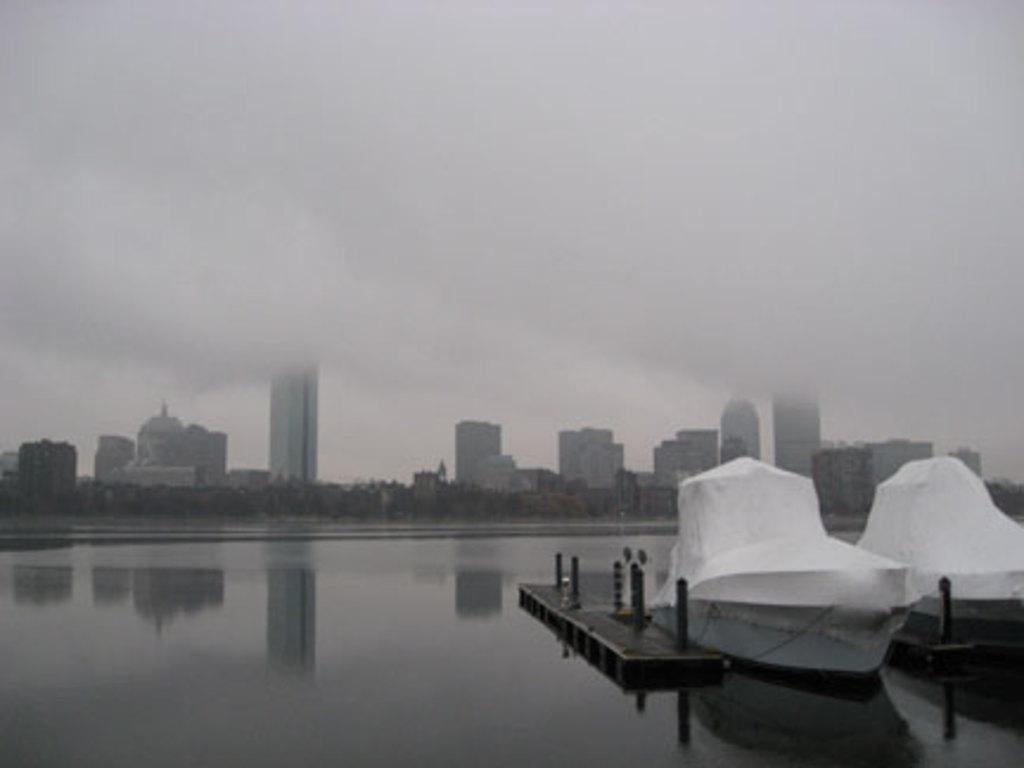Please provide a concise description of this image. In the foreground I can see boats in the water and a fence. In the background I can see trees, buildings and the sky. This image is taken may be during a day. 